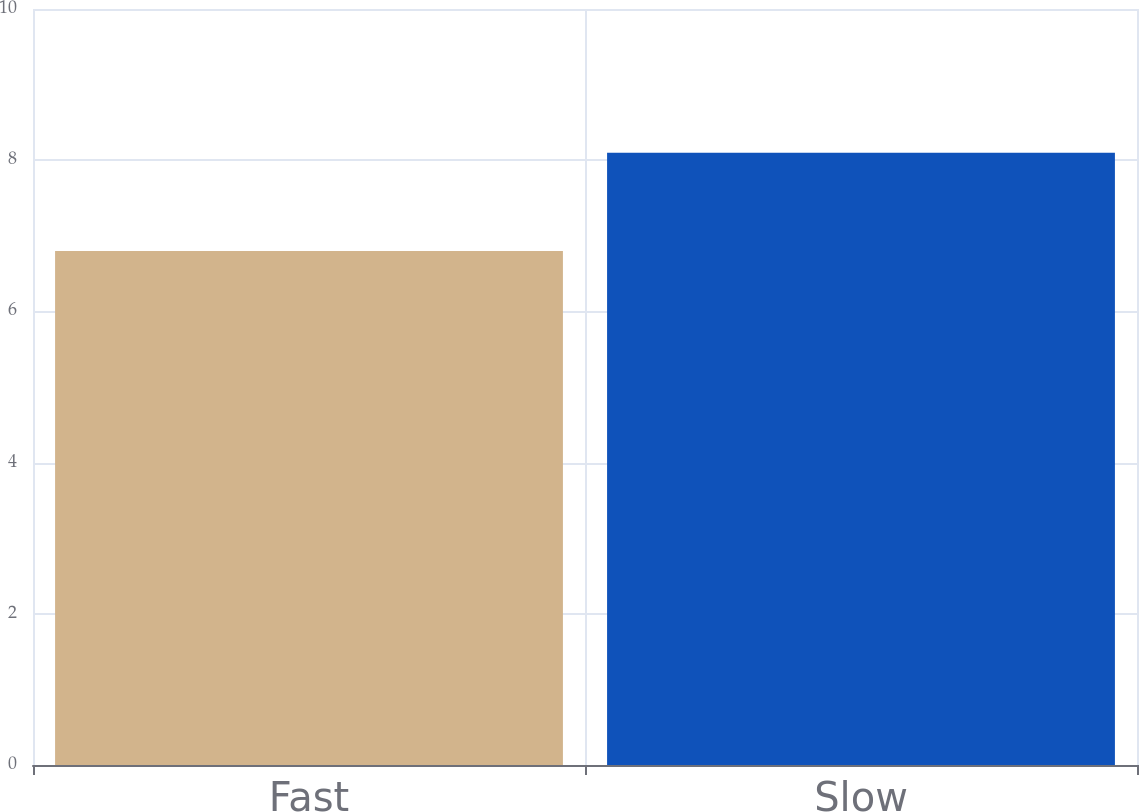Convert chart to OTSL. <chart><loc_0><loc_0><loc_500><loc_500><bar_chart><fcel>Fast<fcel>Slow<nl><fcel>6.8<fcel>8.1<nl></chart> 